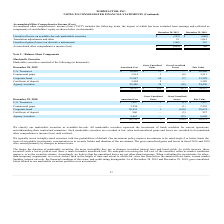According to Formfactor's financial document, How is marketable securities classified? We classify our marketable securities as available-for-sale.. The document states: "We classify our marketable securities as available-for-sale. All marketable securities represent the investment of funds available for current operati..." Also, can you calculate: What is the increase/ (decrease) in Amortized Cost of U.S. Treasuries from Fiscal Year Ended December 28, 2019 to December 29, 2018? Based on the calculation: 10,458-7,997, the result is 2461 (in thousands). This is based on the information: "U.S. Treasuries $ 10,458 $ 11 $ — $ 10,469 U.S. Treasuries $ 7,997 $ 1 $ (1) $ 7,997..." The key data points involved are: 10,458, 7,997. Also, can you calculate: What is the increase/ (decrease) in Amortized Cost of Commercial paper from Fiscal Year Ended December 28, 2019 to December 29, 2018? Based on the calculation: 3,914-2,296, the result is 1618 (in thousands). This is based on the information: "Commercial paper 3,914 1 (4) 3,911 Commercial paper 2,296 — (1) 2,295..." The key data points involved are: 2,296, 3,914. Also, can you calculate: What was the difference between the fair value of Commercial paper compared to U.S. Treasuries? Based on the calculation: 10,469 - 3,911, the result is 6558 (in thousands). This is based on the information: "U.S. Treasuries $ 10,458 $ 11 $ — $ 10,469 Commercial paper 3,914 1 (4) 3,911..." The key data points involved are: 10,469, 3,911. Also, What was the fair value of corporate bond? According to the financial document, 33,928 (in thousands). The relevant text states: "Corporate bond 33,867 68 (7) 33,928..." Also, Where does the company typically invest? highly-rated securities with low probabilities of default. The document states: "We typically invest in highly-rated securities with low probabilities of default. Our investment policy requires investments to be rated single A or b..." 